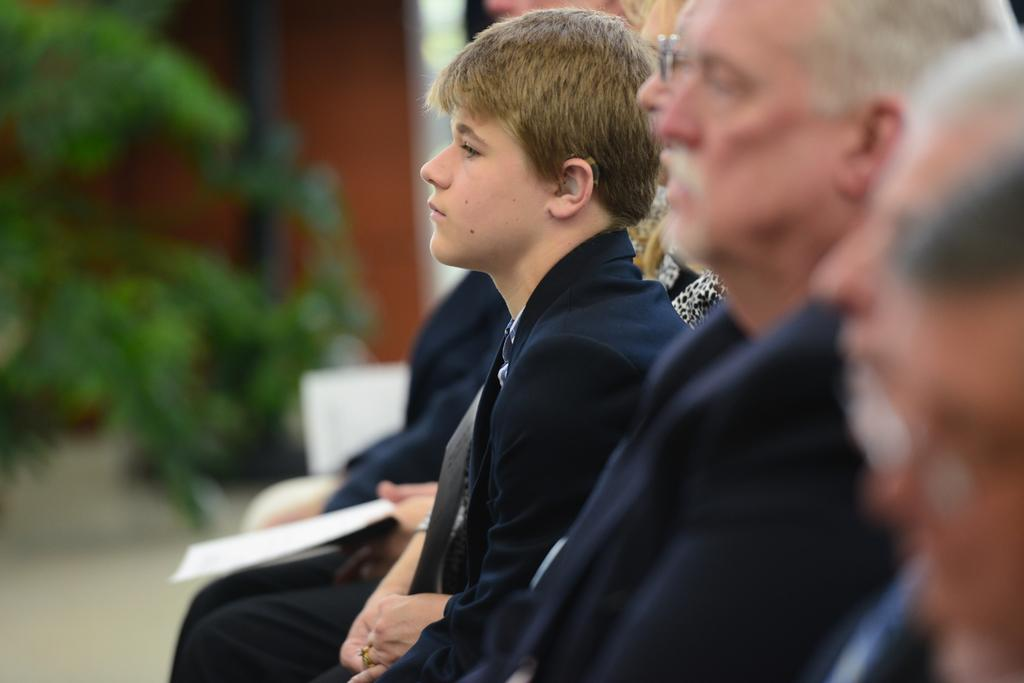Who or what is present in the image? There are people in the image. Where are the people located in the image? The people are in the middle of the image. What can be observed about the background of the image? The background of the image is blurred. What type of coat is the can wearing in the image? There is no can present in the image, and therefore no coat can be observed. 